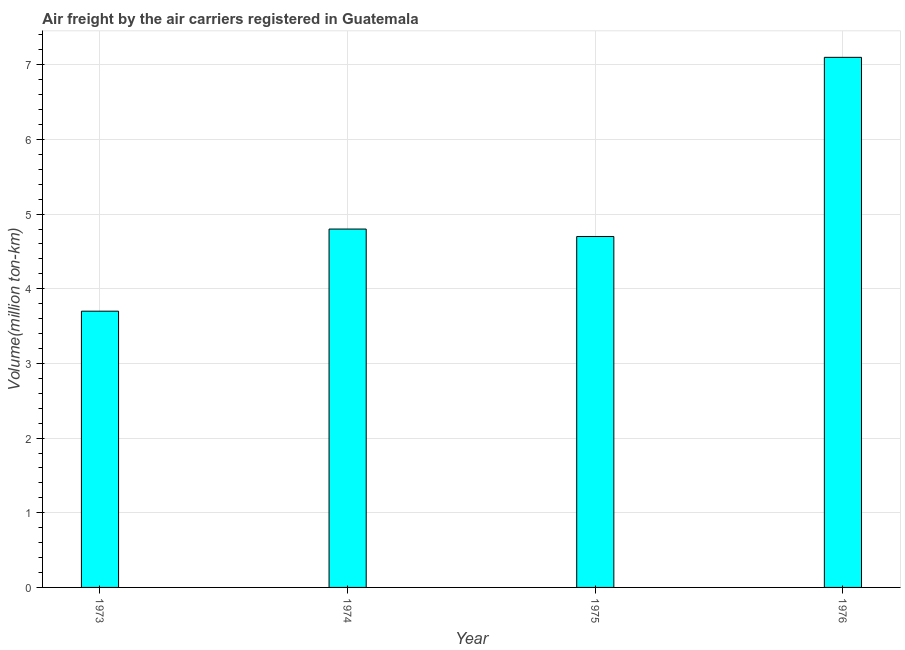Does the graph contain any zero values?
Provide a short and direct response. No. Does the graph contain grids?
Your response must be concise. Yes. What is the title of the graph?
Ensure brevity in your answer.  Air freight by the air carriers registered in Guatemala. What is the label or title of the X-axis?
Offer a terse response. Year. What is the label or title of the Y-axis?
Keep it short and to the point. Volume(million ton-km). What is the air freight in 1976?
Offer a very short reply. 7.1. Across all years, what is the maximum air freight?
Your answer should be compact. 7.1. Across all years, what is the minimum air freight?
Your answer should be very brief. 3.7. In which year was the air freight maximum?
Keep it short and to the point. 1976. What is the sum of the air freight?
Give a very brief answer. 20.3. What is the difference between the air freight in 1975 and 1976?
Offer a very short reply. -2.4. What is the average air freight per year?
Make the answer very short. 5.08. What is the median air freight?
Your answer should be compact. 4.75. In how many years, is the air freight greater than 0.4 million ton-km?
Keep it short and to the point. 4. Do a majority of the years between 1975 and 1973 (inclusive) have air freight greater than 5 million ton-km?
Make the answer very short. Yes. What is the ratio of the air freight in 1973 to that in 1974?
Keep it short and to the point. 0.77. Is the air freight in 1973 less than that in 1976?
Your answer should be very brief. Yes. Is the difference between the air freight in 1973 and 1974 greater than the difference between any two years?
Offer a very short reply. No. How many bars are there?
Your answer should be compact. 4. What is the difference between two consecutive major ticks on the Y-axis?
Provide a short and direct response. 1. Are the values on the major ticks of Y-axis written in scientific E-notation?
Ensure brevity in your answer.  No. What is the Volume(million ton-km) in 1973?
Provide a short and direct response. 3.7. What is the Volume(million ton-km) of 1974?
Give a very brief answer. 4.8. What is the Volume(million ton-km) of 1975?
Provide a succinct answer. 4.7. What is the Volume(million ton-km) of 1976?
Your answer should be very brief. 7.1. What is the difference between the Volume(million ton-km) in 1973 and 1974?
Provide a short and direct response. -1.1. What is the difference between the Volume(million ton-km) in 1974 and 1975?
Your answer should be compact. 0.1. What is the difference between the Volume(million ton-km) in 1974 and 1976?
Your answer should be very brief. -2.3. What is the difference between the Volume(million ton-km) in 1975 and 1976?
Give a very brief answer. -2.4. What is the ratio of the Volume(million ton-km) in 1973 to that in 1974?
Provide a short and direct response. 0.77. What is the ratio of the Volume(million ton-km) in 1973 to that in 1975?
Your response must be concise. 0.79. What is the ratio of the Volume(million ton-km) in 1973 to that in 1976?
Your answer should be very brief. 0.52. What is the ratio of the Volume(million ton-km) in 1974 to that in 1975?
Ensure brevity in your answer.  1.02. What is the ratio of the Volume(million ton-km) in 1974 to that in 1976?
Your answer should be very brief. 0.68. What is the ratio of the Volume(million ton-km) in 1975 to that in 1976?
Give a very brief answer. 0.66. 